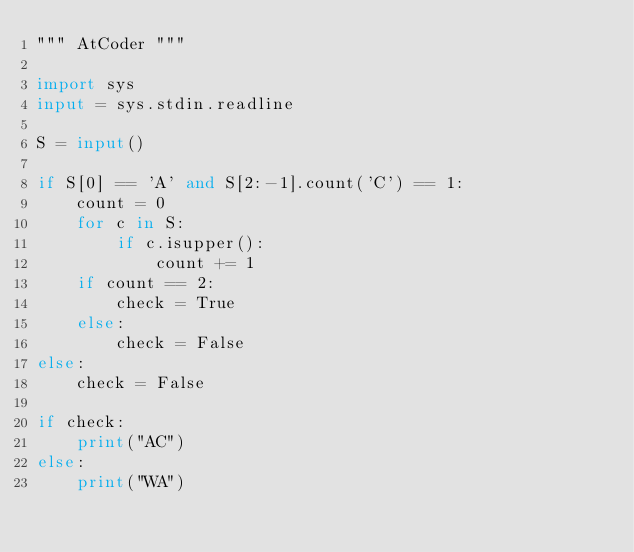Convert code to text. <code><loc_0><loc_0><loc_500><loc_500><_Python_>""" AtCoder """

import sys
input = sys.stdin.readline

S = input()

if S[0] == 'A' and S[2:-1].count('C') == 1:
    count = 0
    for c in S:
        if c.isupper():
            count += 1
    if count == 2:
        check = True
    else:
        check = False
else:
    check = False

if check:
    print("AC")
else:
    print("WA")
</code> 